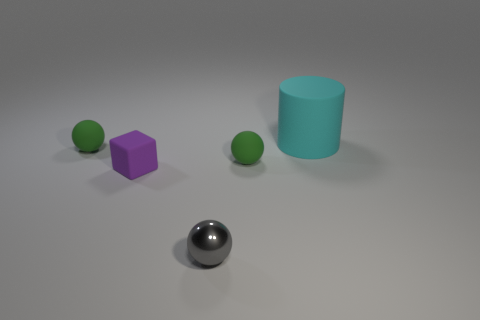Add 5 cubes. How many objects exist? 10 Subtract all balls. How many objects are left? 2 Subtract all tiny rubber cubes. Subtract all metallic spheres. How many objects are left? 3 Add 4 matte cubes. How many matte cubes are left? 5 Add 4 matte things. How many matte things exist? 8 Subtract 1 purple cubes. How many objects are left? 4 